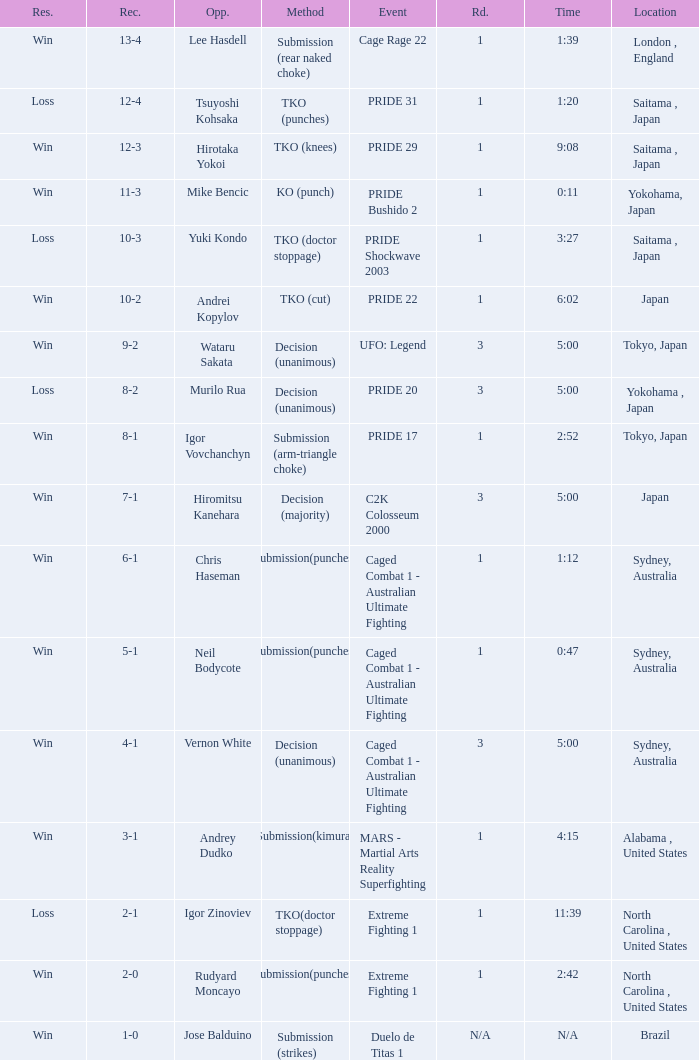Which Res has a Method of decision (unanimous) and an Opponent of Wataru Sakata? Win. 